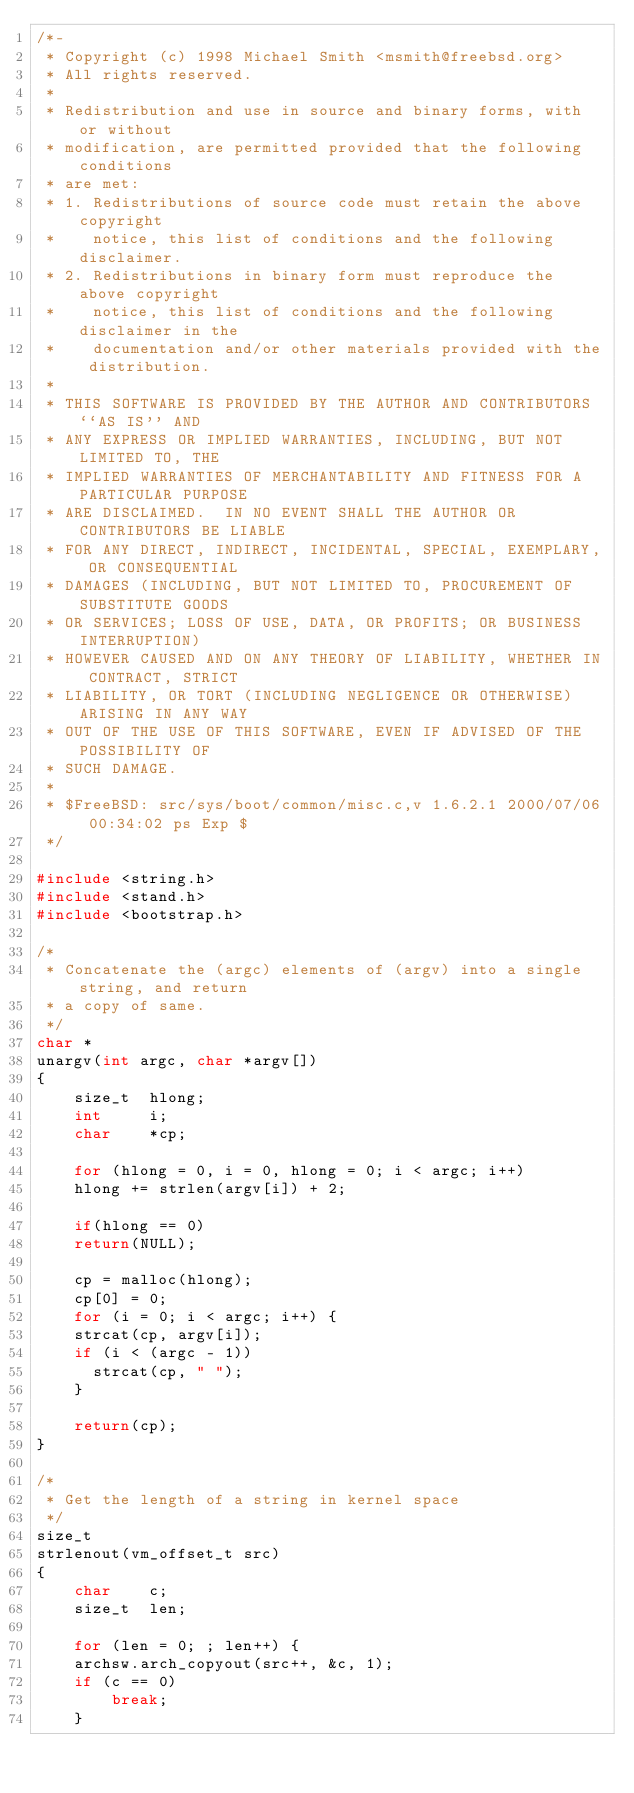Convert code to text. <code><loc_0><loc_0><loc_500><loc_500><_C_>/*-
 * Copyright (c) 1998 Michael Smith <msmith@freebsd.org>
 * All rights reserved.
 *
 * Redistribution and use in source and binary forms, with or without
 * modification, are permitted provided that the following conditions
 * are met:
 * 1. Redistributions of source code must retain the above copyright
 *    notice, this list of conditions and the following disclaimer.
 * 2. Redistributions in binary form must reproduce the above copyright
 *    notice, this list of conditions and the following disclaimer in the
 *    documentation and/or other materials provided with the distribution.
 *
 * THIS SOFTWARE IS PROVIDED BY THE AUTHOR AND CONTRIBUTORS ``AS IS'' AND
 * ANY EXPRESS OR IMPLIED WARRANTIES, INCLUDING, BUT NOT LIMITED TO, THE
 * IMPLIED WARRANTIES OF MERCHANTABILITY AND FITNESS FOR A PARTICULAR PURPOSE
 * ARE DISCLAIMED.  IN NO EVENT SHALL THE AUTHOR OR CONTRIBUTORS BE LIABLE
 * FOR ANY DIRECT, INDIRECT, INCIDENTAL, SPECIAL, EXEMPLARY, OR CONSEQUENTIAL
 * DAMAGES (INCLUDING, BUT NOT LIMITED TO, PROCUREMENT OF SUBSTITUTE GOODS
 * OR SERVICES; LOSS OF USE, DATA, OR PROFITS; OR BUSINESS INTERRUPTION)
 * HOWEVER CAUSED AND ON ANY THEORY OF LIABILITY, WHETHER IN CONTRACT, STRICT
 * LIABILITY, OR TORT (INCLUDING NEGLIGENCE OR OTHERWISE) ARISING IN ANY WAY
 * OUT OF THE USE OF THIS SOFTWARE, EVEN IF ADVISED OF THE POSSIBILITY OF
 * SUCH DAMAGE.
 *
 * $FreeBSD: src/sys/boot/common/misc.c,v 1.6.2.1 2000/07/06 00:34:02 ps Exp $
 */

#include <string.h>
#include <stand.h>
#include <bootstrap.h>

/*
 * Concatenate the (argc) elements of (argv) into a single string, and return
 * a copy of same.
 */
char *
unargv(int argc, char *argv[])
{
    size_t	hlong;
    int		i;
    char	*cp;

    for (hlong = 0, i = 0, hlong = 0; i < argc; i++)
	hlong += strlen(argv[i]) + 2;

    if(hlong == 0)
	return(NULL);

    cp = malloc(hlong);
    cp[0] = 0;
    for (i = 0; i < argc; i++) {
	strcat(cp, argv[i]);
	if (i < (argc - 1))
	  strcat(cp, " ");
    }
	  
    return(cp);
}

/*
 * Get the length of a string in kernel space
 */
size_t
strlenout(vm_offset_t src)
{
    char	c;
    size_t	len;
    
    for (len = 0; ; len++) {
	archsw.arch_copyout(src++, &c, 1);
	if (c == 0)
	    break;
    }</code> 